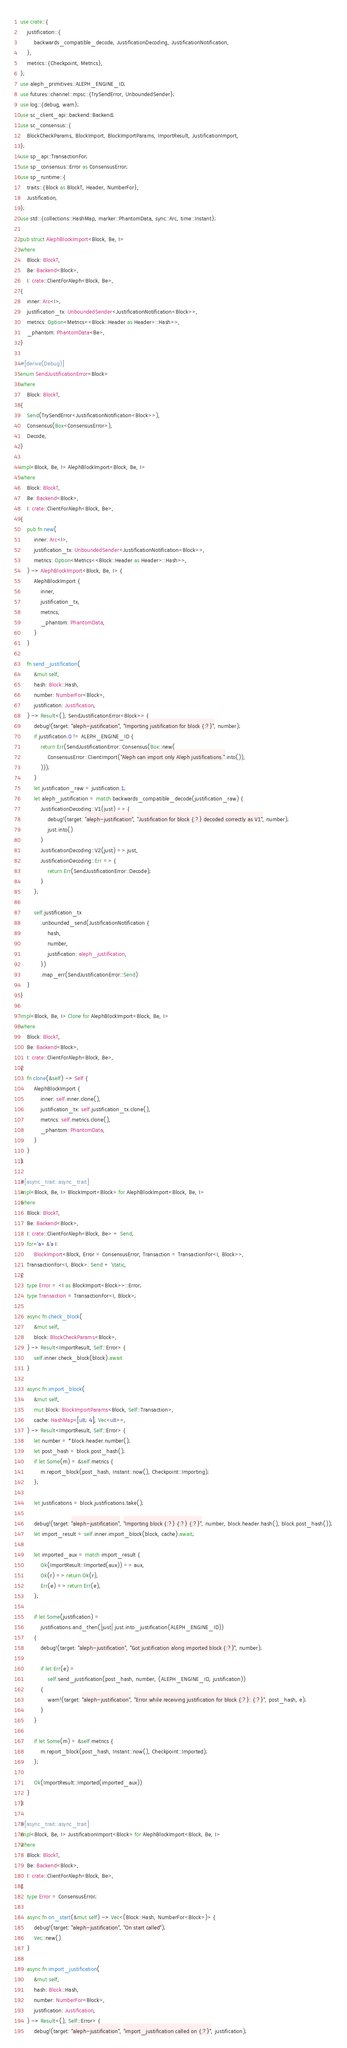Convert code to text. <code><loc_0><loc_0><loc_500><loc_500><_Rust_>use crate::{
    justification::{
        backwards_compatible_decode, JustificationDecoding, JustificationNotification,
    },
    metrics::{Checkpoint, Metrics},
};
use aleph_primitives::ALEPH_ENGINE_ID;
use futures::channel::mpsc::{TrySendError, UnboundedSender};
use log::{debug, warn};
use sc_client_api::backend::Backend;
use sc_consensus::{
    BlockCheckParams, BlockImport, BlockImportParams, ImportResult, JustificationImport,
};
use sp_api::TransactionFor;
use sp_consensus::Error as ConsensusError;
use sp_runtime::{
    traits::{Block as BlockT, Header, NumberFor},
    Justification,
};
use std::{collections::HashMap, marker::PhantomData, sync::Arc, time::Instant};

pub struct AlephBlockImport<Block, Be, I>
where
    Block: BlockT,
    Be: Backend<Block>,
    I: crate::ClientForAleph<Block, Be>,
{
    inner: Arc<I>,
    justification_tx: UnboundedSender<JustificationNotification<Block>>,
    metrics: Option<Metrics<<Block::Header as Header>::Hash>>,
    _phantom: PhantomData<Be>,
}

#[derive(Debug)]
enum SendJustificationError<Block>
where
    Block: BlockT,
{
    Send(TrySendError<JustificationNotification<Block>>),
    Consensus(Box<ConsensusError>),
    Decode,
}

impl<Block, Be, I> AlephBlockImport<Block, Be, I>
where
    Block: BlockT,
    Be: Backend<Block>,
    I: crate::ClientForAleph<Block, Be>,
{
    pub fn new(
        inner: Arc<I>,
        justification_tx: UnboundedSender<JustificationNotification<Block>>,
        metrics: Option<Metrics<<Block::Header as Header>::Hash>>,
    ) -> AlephBlockImport<Block, Be, I> {
        AlephBlockImport {
            inner,
            justification_tx,
            metrics,
            _phantom: PhantomData,
        }
    }

    fn send_justification(
        &mut self,
        hash: Block::Hash,
        number: NumberFor<Block>,
        justification: Justification,
    ) -> Result<(), SendJustificationError<Block>> {
        debug!(target: "aleph-justification", "Importing justification for block {:?}", number);
        if justification.0 != ALEPH_ENGINE_ID {
            return Err(SendJustificationError::Consensus(Box::new(
                ConsensusError::ClientImport("Aleph can import only Aleph justifications.".into()),
            )));
        }
        let justification_raw = justification.1;
        let aleph_justification = match backwards_compatible_decode(justification_raw) {
            JustificationDecoding::V1(just) => {
                debug!(target: "aleph-justification", "Justification for block {:?} decoded correctly as V1", number);
                just.into()
            }
            JustificationDecoding::V2(just) => just,
            JustificationDecoding::Err => {
                return Err(SendJustificationError::Decode);
            }
        };

        self.justification_tx
            .unbounded_send(JustificationNotification {
                hash,
                number,
                justification: aleph_justification,
            })
            .map_err(SendJustificationError::Send)
    }
}

impl<Block, Be, I> Clone for AlephBlockImport<Block, Be, I>
where
    Block: BlockT,
    Be: Backend<Block>,
    I: crate::ClientForAleph<Block, Be>,
{
    fn clone(&self) -> Self {
        AlephBlockImport {
            inner: self.inner.clone(),
            justification_tx: self.justification_tx.clone(),
            metrics: self.metrics.clone(),
            _phantom: PhantomData,
        }
    }
}

#[async_trait::async_trait]
impl<Block, Be, I> BlockImport<Block> for AlephBlockImport<Block, Be, I>
where
    Block: BlockT,
    Be: Backend<Block>,
    I: crate::ClientForAleph<Block, Be> + Send,
    for<'a> &'a I:
        BlockImport<Block, Error = ConsensusError, Transaction = TransactionFor<I, Block>>,
    TransactionFor<I, Block>: Send + 'static,
{
    type Error = <I as BlockImport<Block>>::Error;
    type Transaction = TransactionFor<I, Block>;

    async fn check_block(
        &mut self,
        block: BlockCheckParams<Block>,
    ) -> Result<ImportResult, Self::Error> {
        self.inner.check_block(block).await
    }

    async fn import_block(
        &mut self,
        mut block: BlockImportParams<Block, Self::Transaction>,
        cache: HashMap<[u8; 4], Vec<u8>>,
    ) -> Result<ImportResult, Self::Error> {
        let number = *block.header.number();
        let post_hash = block.post_hash();
        if let Some(m) = &self.metrics {
            m.report_block(post_hash, Instant::now(), Checkpoint::Importing);
        };

        let justifications = block.justifications.take();

        debug!(target: "aleph-justification", "Importing block {:?} {:?} {:?}", number, block.header.hash(), block.post_hash());
        let import_result = self.inner.import_block(block, cache).await;

        let imported_aux = match import_result {
            Ok(ImportResult::Imported(aux)) => aux,
            Ok(r) => return Ok(r),
            Err(e) => return Err(e),
        };

        if let Some(justification) =
            justifications.and_then(|just| just.into_justification(ALEPH_ENGINE_ID))
        {
            debug!(target: "aleph-justification", "Got justification along imported block {:?}", number);

            if let Err(e) =
                self.send_justification(post_hash, number, (ALEPH_ENGINE_ID, justification))
            {
                warn!(target: "aleph-justification", "Error while receiving justification for block {:?}: {:?}", post_hash, e);
            }
        }

        if let Some(m) = &self.metrics {
            m.report_block(post_hash, Instant::now(), Checkpoint::Imported);
        };

        Ok(ImportResult::Imported(imported_aux))
    }
}

#[async_trait::async_trait]
impl<Block, Be, I> JustificationImport<Block> for AlephBlockImport<Block, Be, I>
where
    Block: BlockT,
    Be: Backend<Block>,
    I: crate::ClientForAleph<Block, Be>,
{
    type Error = ConsensusError;

    async fn on_start(&mut self) -> Vec<(Block::Hash, NumberFor<Block>)> {
        debug!(target: "aleph-justification", "On start called");
        Vec::new()
    }

    async fn import_justification(
        &mut self,
        hash: Block::Hash,
        number: NumberFor<Block>,
        justification: Justification,
    ) -> Result<(), Self::Error> {
        debug!(target: "aleph-justification", "import_justification called on {:?}", justification);</code> 